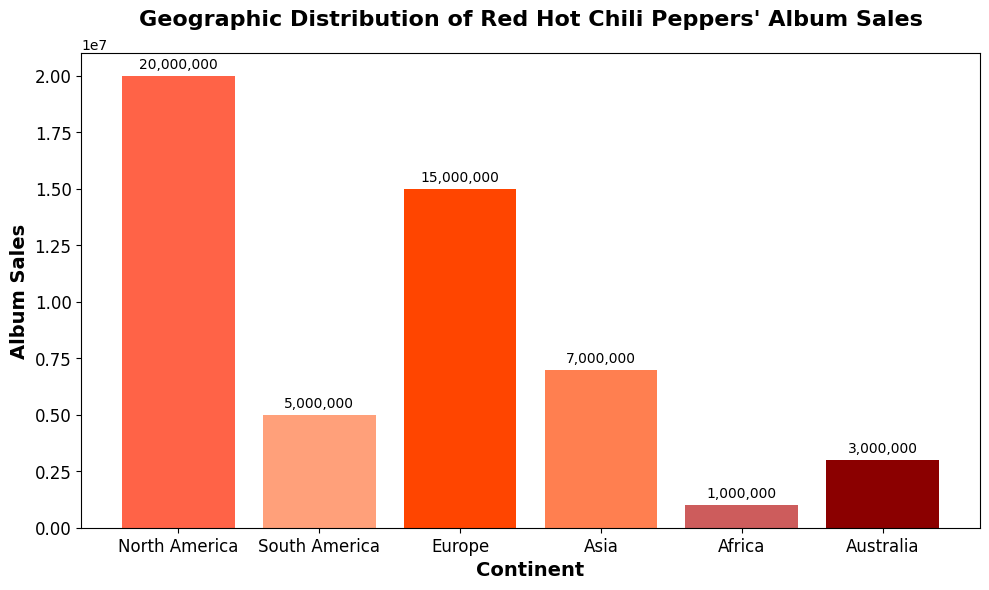What's the continent with the highest album sales? The figure shows the album sales for each continent, and North America has the tallest bar. Therefore, North America has the highest album sales.
Answer: North America Which continent has the lowest album sales? By observing the heights of the bars in the figure, Africa has the shortest bar, indicating it has the lowest album sales.
Answer: Africa How many more albums did Red Hot Chili Peppers sell in Europe compared to Australia? Europe has 15,000,000 album sales and Australia has 3,000,000. The difference is 15,000,000 - 3,000,000 = 12,000,000.
Answer: 12,000,000 What is the total album sales in Asia and South America combined? Asia has 7,000,000 album sales and South America has 5,000,000. The combined total is 7,000,000 + 5,000,000 = 12,000,000.
Answer: 12,000,000 Which continent has more album sales, Asia or South America, and by how much? Asia has 7,000,000 album sales and South America has 5,000,000. Asia has more sales by 7,000,000 - 5,000,000 = 2,000,000.
Answer: Asia, by 2,000,000 What is the average album sales across all the continents? The album sales for all continents are: 20,000,000 + 5,000,000 + 15,000,000 + 7,000,000 + 1,000,000 + 3,000,000. The total is 51,000,000. The average across 6 continents is 51,000,000 / 6 = 8,500,000.
Answer: 8,500,000 What color is the bar representing South America's album sales? By looking at the bar colors in the figure, the bar for South America appears in a light orange color.
Answer: Light orange Which continents have album sales greater than 6 million? The continents with album sales greater than 6,000,000 are North America (20,000,000), Europe (15,000,000), and Asia (7,000,000).
Answer: North America, Europe, Asia What is the difference in album sales between the continent with the highest and the lowest sales? North America has the highest album sales with 20,000,000, and Africa has the lowest with 1,000,000. The difference is 20,000,000 - 1,000,000 = 19,000,000.
Answer: 19,000,000 